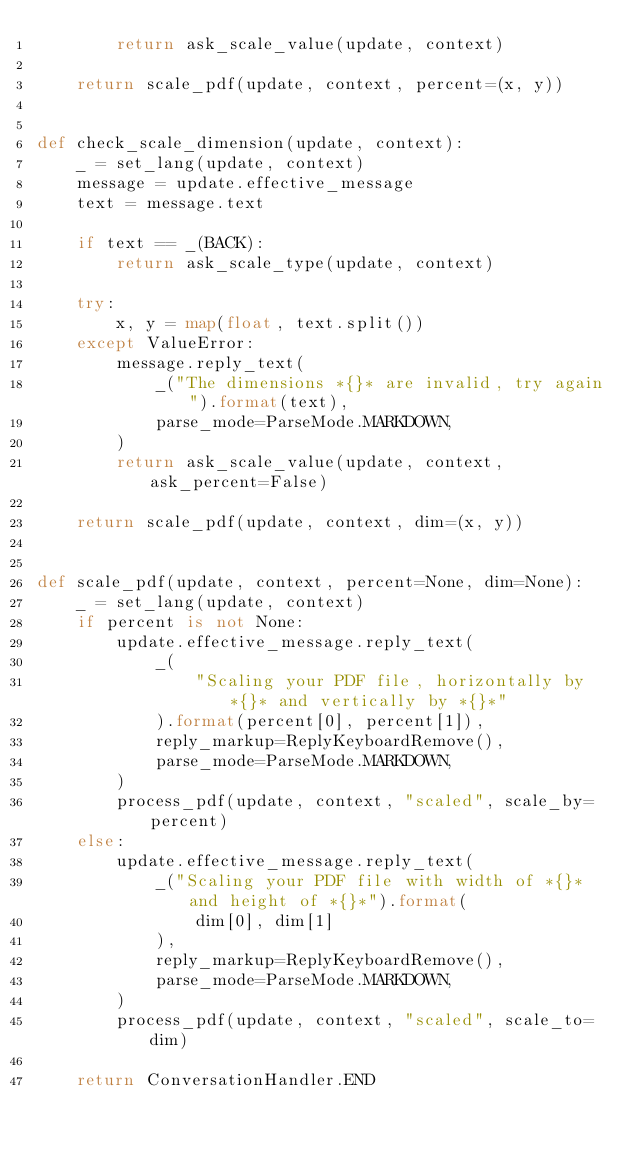<code> <loc_0><loc_0><loc_500><loc_500><_Python_>        return ask_scale_value(update, context)

    return scale_pdf(update, context, percent=(x, y))


def check_scale_dimension(update, context):
    _ = set_lang(update, context)
    message = update.effective_message
    text = message.text

    if text == _(BACK):
        return ask_scale_type(update, context)

    try:
        x, y = map(float, text.split())
    except ValueError:
        message.reply_text(
            _("The dimensions *{}* are invalid, try again").format(text),
            parse_mode=ParseMode.MARKDOWN,
        )
        return ask_scale_value(update, context, ask_percent=False)

    return scale_pdf(update, context, dim=(x, y))


def scale_pdf(update, context, percent=None, dim=None):
    _ = set_lang(update, context)
    if percent is not None:
        update.effective_message.reply_text(
            _(
                "Scaling your PDF file, horizontally by *{}* and vertically by *{}*"
            ).format(percent[0], percent[1]),
            reply_markup=ReplyKeyboardRemove(),
            parse_mode=ParseMode.MARKDOWN,
        )
        process_pdf(update, context, "scaled", scale_by=percent)
    else:
        update.effective_message.reply_text(
            _("Scaling your PDF file with width of *{}* and height of *{}*").format(
                dim[0], dim[1]
            ),
            reply_markup=ReplyKeyboardRemove(),
            parse_mode=ParseMode.MARKDOWN,
        )
        process_pdf(update, context, "scaled", scale_to=dim)

    return ConversationHandler.END
</code> 